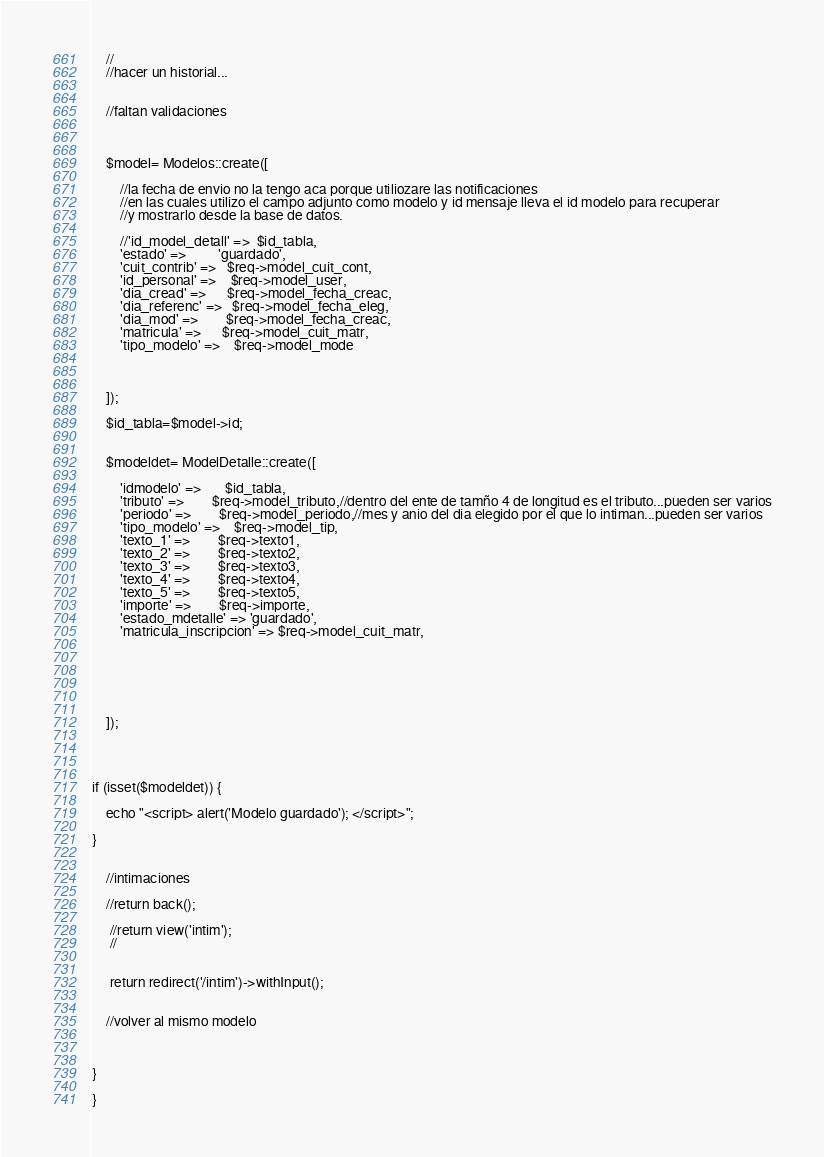<code> <loc_0><loc_0><loc_500><loc_500><_PHP_>	//
	//hacer un historial...
	

	//faltan validaciones
	


	$model= Modelos::create([

		//la fecha de envio no la tengo aca porque utiliozare las notificaciones
		//en las cuales utilizo el campo adjunto como modelo y id mensaje lleva el id modelo para recuperar
		//y mostrarlo desde la base de datos.

		//'id_model_detall' => 	$id_tabla,
		'estado' => 		'guardado',
		'cuit_contrib' => 	$req->model_cuit_cont,
		'id_personal' => 	$req->model_user,
		'dia_cread' => 		$req->model_fecha_creac,
		'dia_referenc' => 	$req->model_fecha_eleg,
		'dia_mod' => 		$req->model_fecha_creac,
		'matricula' => 		$req->model_cuit_matr,
		'tipo_modelo' =>    $req->model_mode



	]);

    $id_tabla=$model->id;


	$modeldet= ModelDetalle::create([

		'idmodelo' =>       $id_tabla,
		'tributo' => 		$req->model_tributo,//dentro del ente de tamño 4 de longitud es el tributo...pueden ser varios
		'periodo' => 		$req->model_periodo,//mes y anio del dia elegido por el que lo intiman...pueden ser varios
		'tipo_modelo' => 	$req->model_tip,
		'texto_1' => 		$req->texto1,
		'texto_2' => 		$req->texto2,
		'texto_3' => 		$req->texto3,
		'texto_4' => 		$req->texto4,
		'texto_5' => 		$req->texto5,
		'importe' => 		$req->importe,
		'estado_mdetalle' => 'guardado',
		'matricula_inscripcion' => $req->model_cuit_matr,






	]);




if (isset($modeldet)) {
	
	echo "<script> alert('Modelo guardado'); </script>";

}
	

	//intimaciones
	
	//return back();

	 //return view('intim');
	 //
	 

	 return redirect('/intim')->withInput();


	//volver al mismo modelo



}

}
</code> 